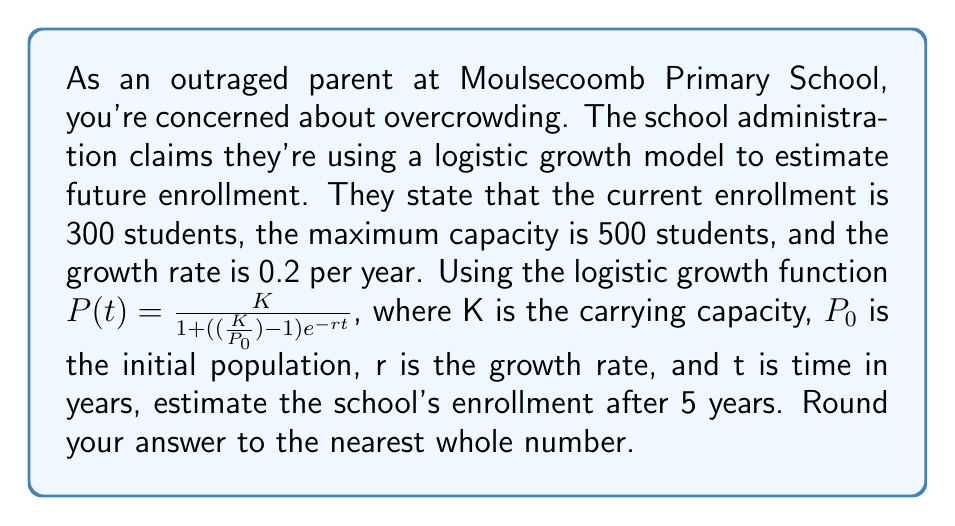Solve this math problem. To solve this problem, we'll use the logistic growth function:

$$ P(t) = \frac{K}{1 + ((\frac{K}{P_0}) - 1)e^{-rt}} $$

Where:
- K = 500 (maximum capacity)
- $P_0$ = 300 (current enrollment)
- r = 0.2 (growth rate per year)
- t = 5 (years)

Let's substitute these values into the equation:

$$ P(5) = \frac{500}{1 + ((\frac{500}{300}) - 1)e^{-0.2(5)}} $$

Simplify the fraction inside the parentheses:
$$ P(5) = \frac{500}{1 + (\frac{5}{3} - 1)e^{-1}} $$

$$ P(5) = \frac{500}{1 + (\frac{2}{3})e^{-1}} $$

Now, let's calculate $e^{-1}$:
$$ e^{-1} \approx 0.3679 $$

Substituting this value:
$$ P(5) = \frac{500}{1 + (\frac{2}{3})(0.3679)} $$

$$ P(5) = \frac{500}{1 + 0.2453} $$

$$ P(5) = \frac{500}{1.2453} $$

$$ P(5) \approx 401.51 $$

Rounding to the nearest whole number:
$$ P(5) \approx 402 $$
Answer: 402 students 